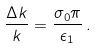Convert formula to latex. <formula><loc_0><loc_0><loc_500><loc_500>\frac { \Delta k } { k } = \frac { \sigma _ { 0 } \pi } { \epsilon _ { 1 } } \, .</formula> 